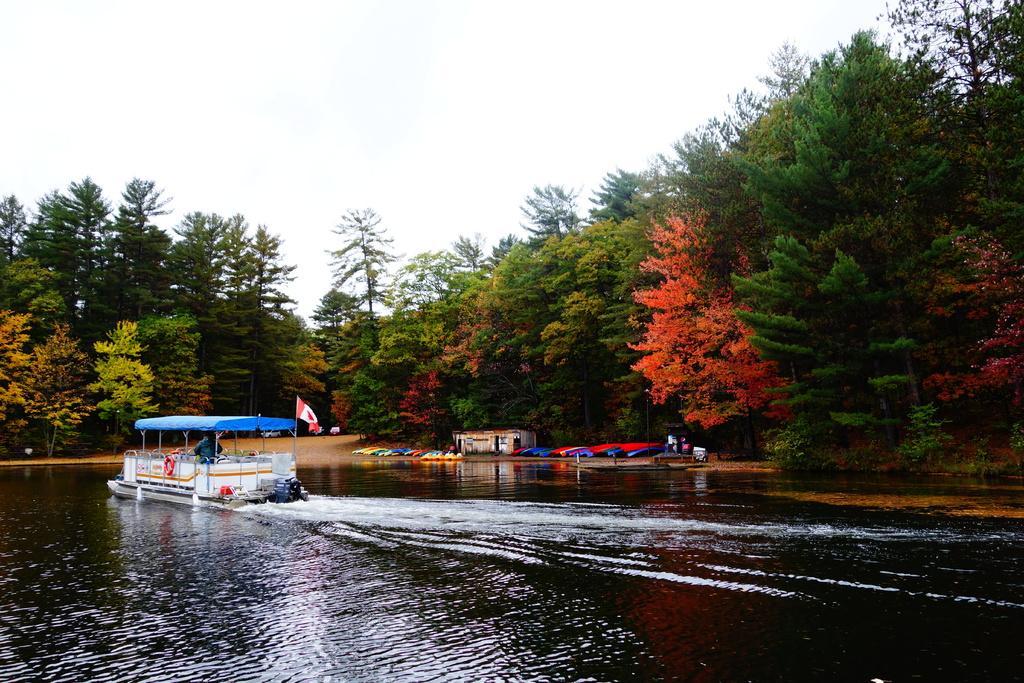In one or two sentences, can you explain what this image depicts? On the left side of the image we can see a boat on the water, in the background we can see few trees, a house and other things, and also we can see a flag. 